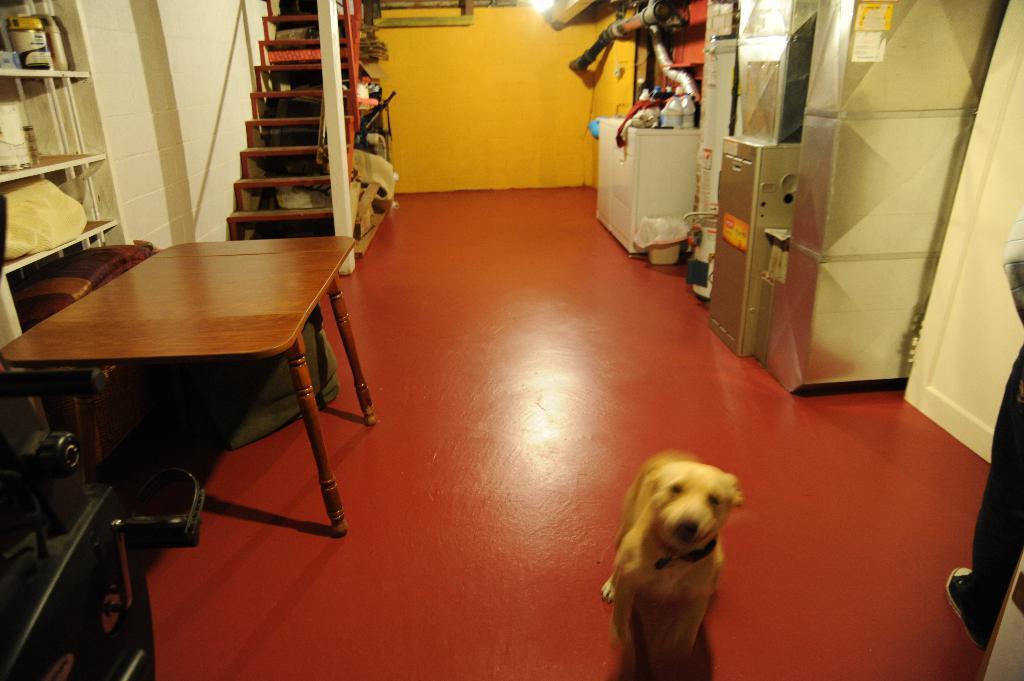In one or two sentences, can you explain what this image depicts? In this image, there is a floor which is in red color on that floor there is a dog standing which is in white color, in the left side there is a table which is in brown color, In the right side there is a object kept, there are some stairs which are in brown color, there is a wall which is in white color. In the background there is a wall which is in yellow color. 